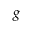<formula> <loc_0><loc_0><loc_500><loc_500>{ g }</formula> 